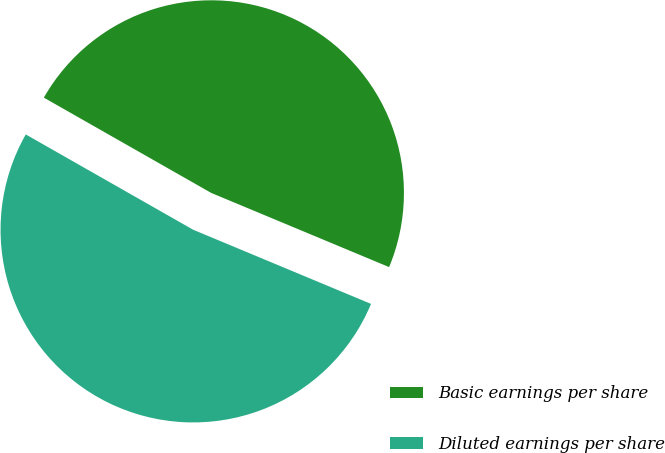Convert chart to OTSL. <chart><loc_0><loc_0><loc_500><loc_500><pie_chart><fcel>Basic earnings per share<fcel>Diluted earnings per share<nl><fcel>48.05%<fcel>51.95%<nl></chart> 